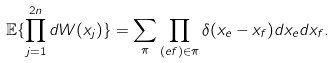<formula> <loc_0><loc_0><loc_500><loc_500>\mathbb { E } \{ \prod _ { j = 1 } ^ { 2 n } d W ( x _ { j } ) \} = \sum _ { \pi } \prod _ { ( e f ) \in \pi } \delta ( x _ { e } - x _ { f } ) d x _ { e } d x _ { f } .</formula> 